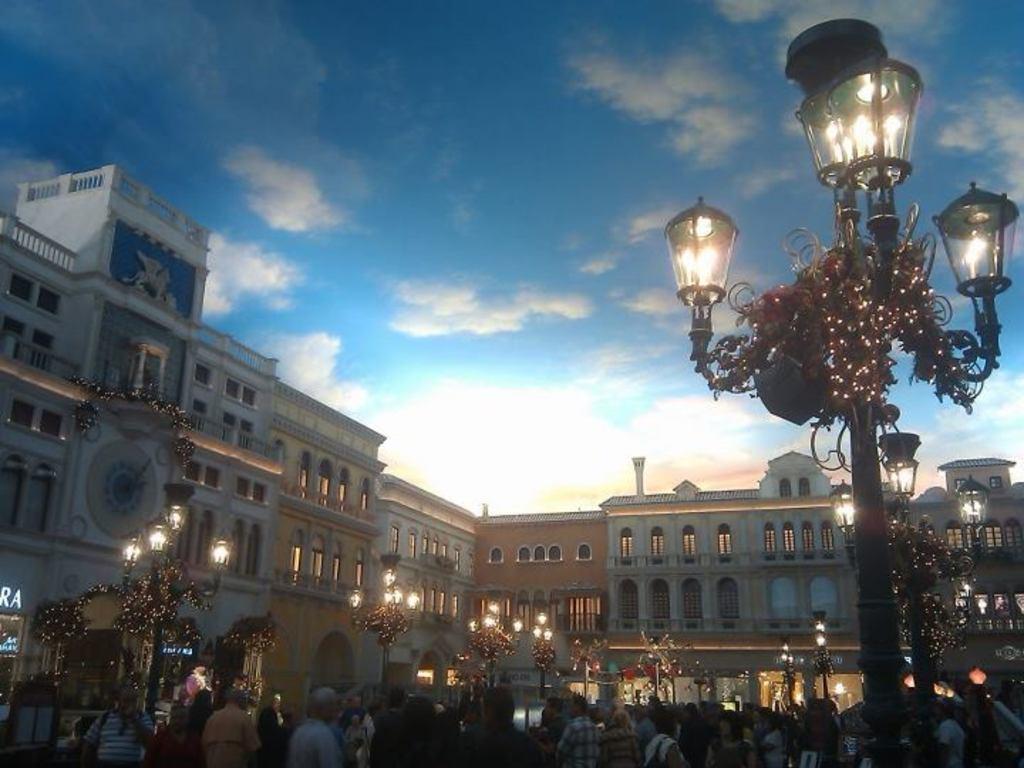Can you describe this image briefly? In this image I can see number of persons are standing, few metal poles with few lights to it and few buildings. In the background I can see the sky. 